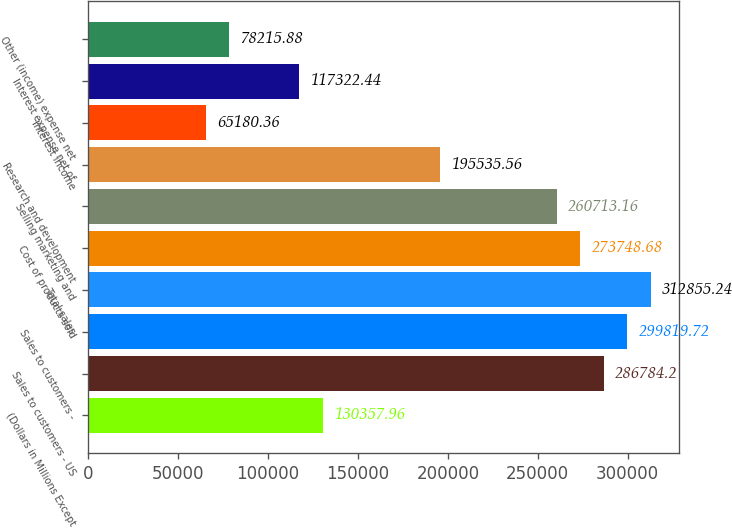<chart> <loc_0><loc_0><loc_500><loc_500><bar_chart><fcel>(Dollars in Millions Except<fcel>Sales to customers - US<fcel>Sales to customers -<fcel>Total sales<fcel>Cost of products sold<fcel>Selling marketing and<fcel>Research and development<fcel>Interest income<fcel>Interest expense net of<fcel>Other (income) expense net<nl><fcel>130358<fcel>286784<fcel>299820<fcel>312855<fcel>273749<fcel>260713<fcel>195536<fcel>65180.4<fcel>117322<fcel>78215.9<nl></chart> 